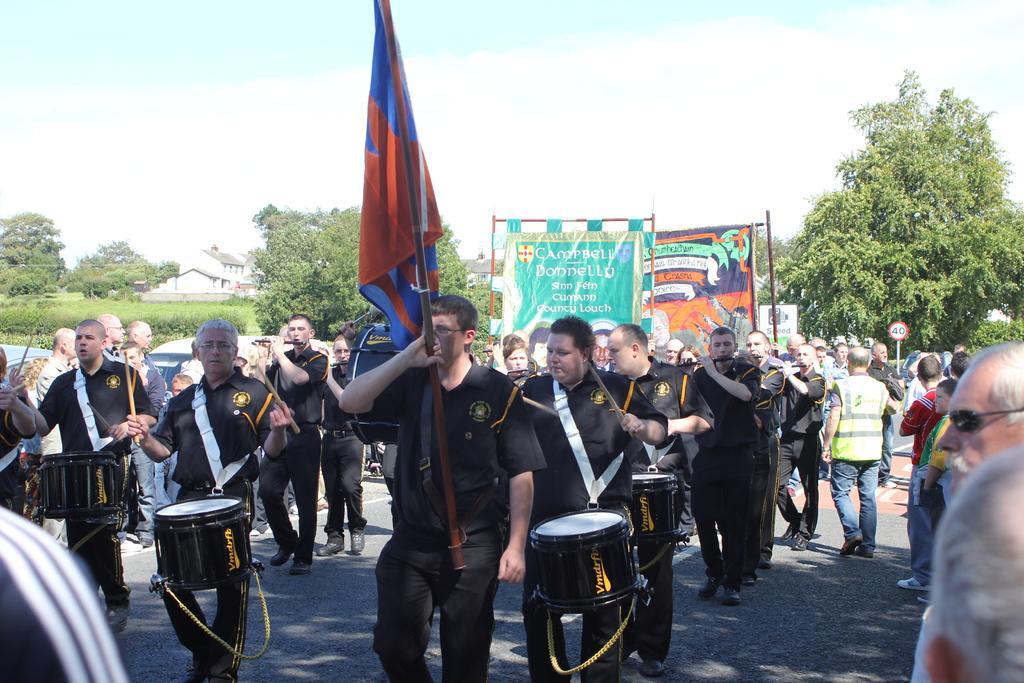Could you give a brief overview of what you see in this image? In this image we can see few persons are walking on the road and among them few persons are holding a flag and hoarding in their hands and a few are holding coffin box in their hands and few are playing drums with sticks in their hands. On the right side few persons are standing. In the background there are trees, buildings, sign board poles and clouds in the sky. 